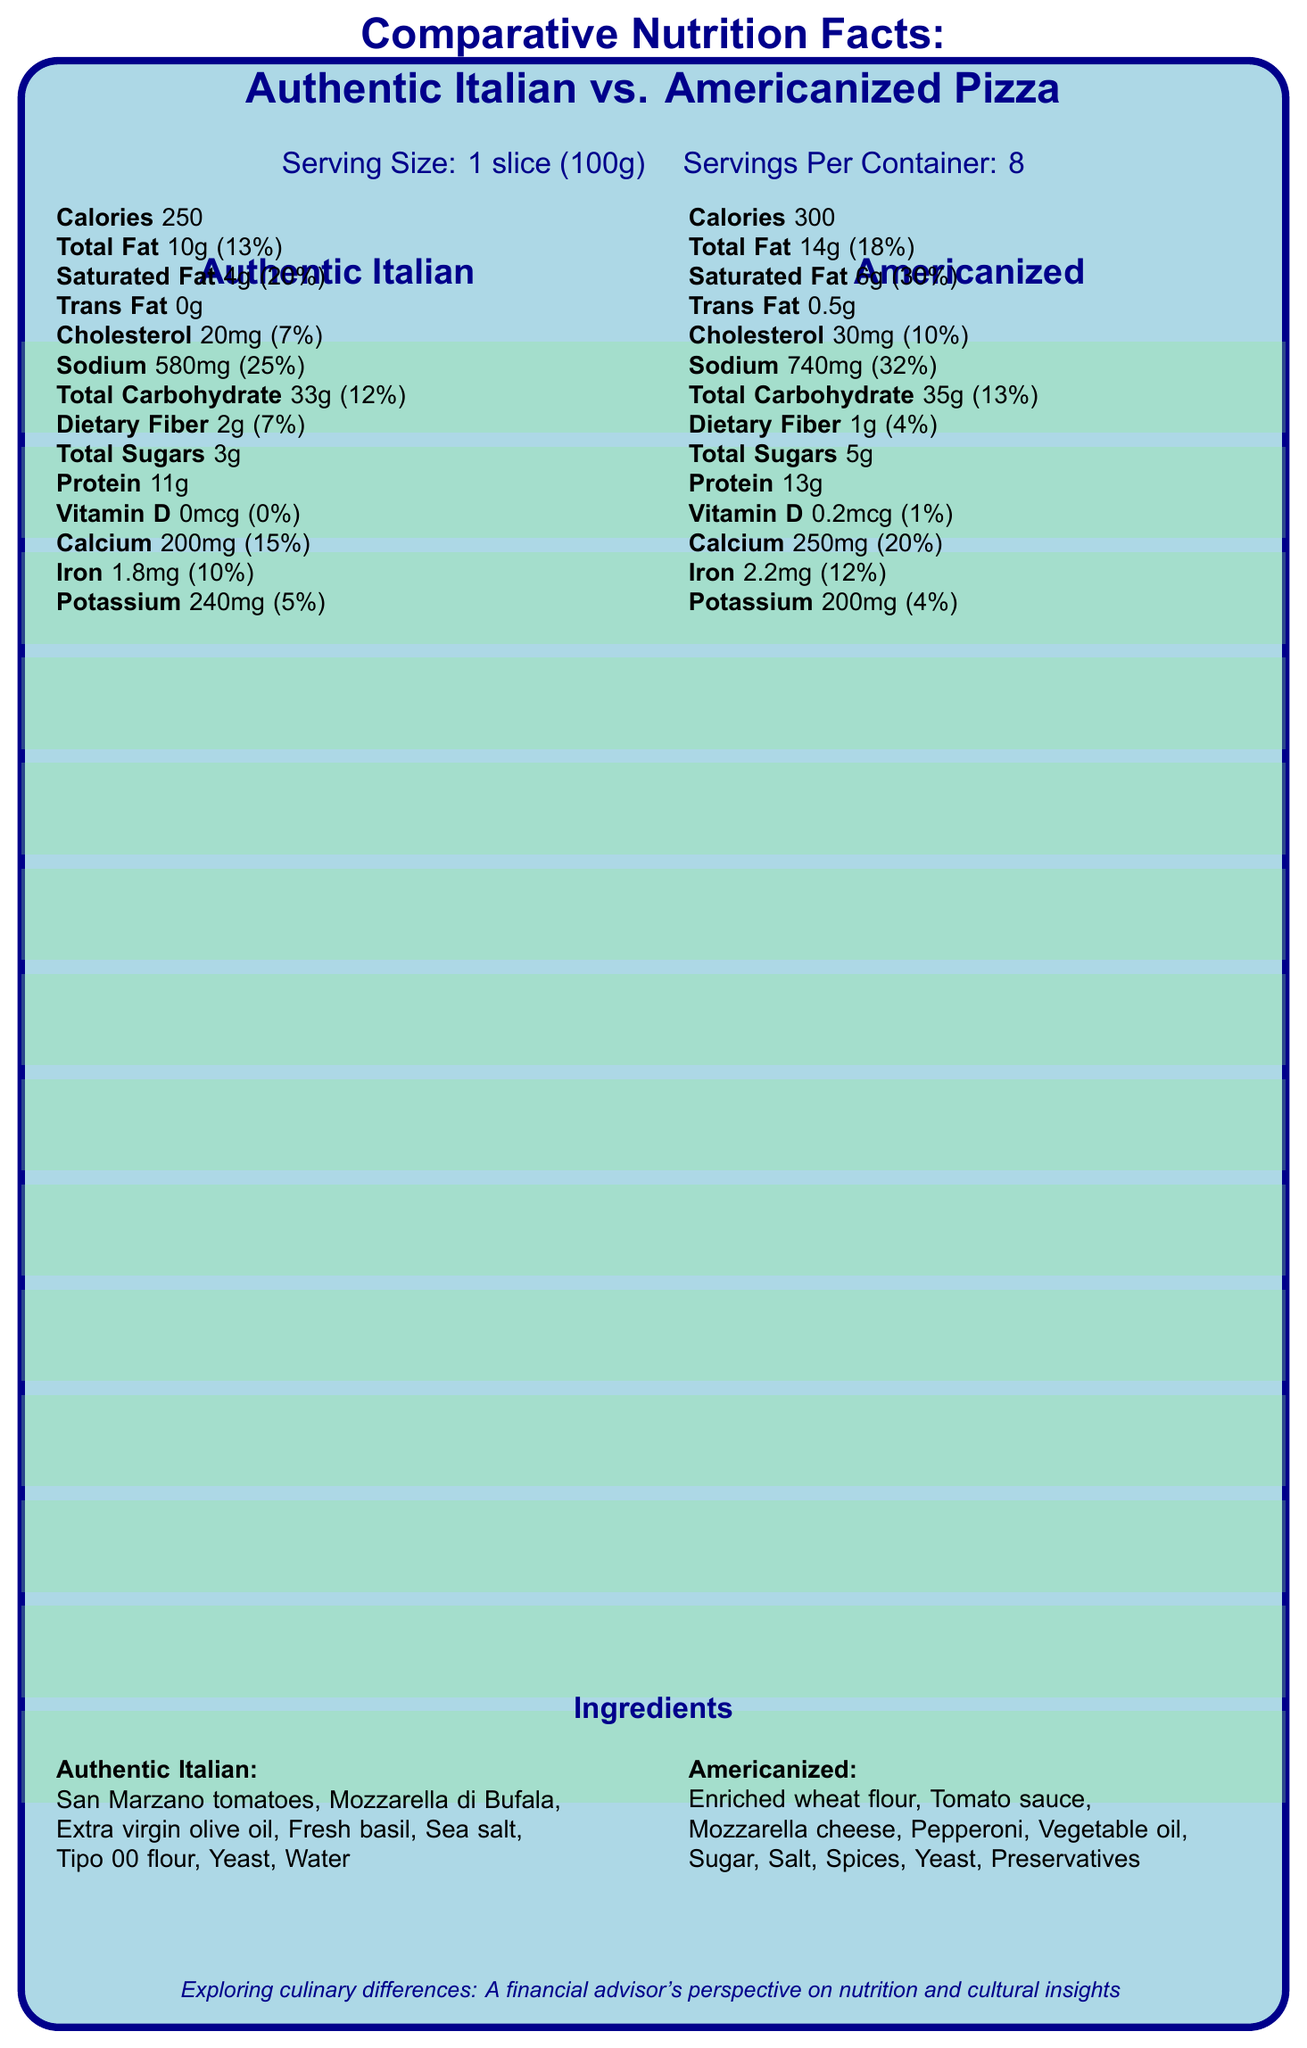what is the serving size for the pizzas? The serving size is clearly stated in the subtitle of the document.
Answer: 1 slice (100g) how many calories are in a slice of Americanized pizza? The calorie content for the Americanized pizza is listed in its respective column.
Answer: 300 what are the main ingredients in authentic Italian pizza? The ingredients for authentic Italian pizza are listed under the section titled "Ingredients".
Answer: San Marzano tomatoes, Mozzarella di Bufala, Extra virgin olive oil, Fresh basil, Sea salt, Tipo 00 flour, Yeast, Water which type of pizza has more saturated fat? A. Authentic Italian B. Americanized C. Both the same The document states that the Americanized pizza has 6g of saturated fat compared to 4g in the authentic Italian pizza.
Answer: B what is the daily value percentage of sodium in authentic Italian pizza? The daily value percentage of sodium for authentic Italian pizza is indicated as 25% in its nutrient column.
Answer: 25% does the authentic Italian pizza contain any trans fat? The authentic Italian pizza is noted to have 0g of trans fat in its nutritional information.
Answer: No how does the fiber content compare between the two types of pizza? The dietary fiber content for each pizza type is listed, with authentic Italian pizza having higher fiber content.
Answer: Authentic Italian pizza contains 2g of dietary fiber, whereas Americanized pizza contains 1g of dietary fiber which pizza has a higher amount of iron content per serving? A. Authentic Italian B. Americanized C. Both have the same The Americanized pizza has 2.2mg of iron, while the authentic Italian pizza has 1.8mg, making the Americanized pizza higher in iron content.
Answer: B does the document provide information on the cost of ingredients? The document lists the ingredients but does not provide any cost information for them.
Answer: Not enough information summarize the main idea of the document. The document presents a detailed comparison between the two pizza styles, including specific nutritional values, ingredients, and additional notes on how these differences relate to health, culture, and financial considerations.
Answer: The document compares the nutritional facts and ingredients of authentic Italian pizza with Americanized pizza. It highlights differences in calorie content, types of fat, sodium, and other nutritional aspects, as well as the cultural significance and financial implications of these differences. based on the document, which type of pizza might be considered healthier in terms of fat content? The authentic Italian pizza has 10g of total fat (13% daily value) and 4g of saturated fat (20% daily value), while the Americanized pizza has 14g of total fat (18% daily value) and 6g of saturated fat (30% daily value), indicating the authentic Italian pizza might be considered healthier.
Answer: Authentic Italian is vitamin D content higher in Americanized pizza? Americanized pizza has 0.2mcg of vitamin D compared to 0mcg in authentic Italian pizza, making it higher in vitamin D.
Answer: Yes how might the higher sodium content in Americanized pizza affect clients with hypertension? The document notes that the higher sodium content in Americanized pizza (32% daily value) could be problematic for clients with hypertension, affecting their long-term financial strategies for healthcare.
Answer: It could be a concern for clients with hypertension or those at risk of heart disease. 